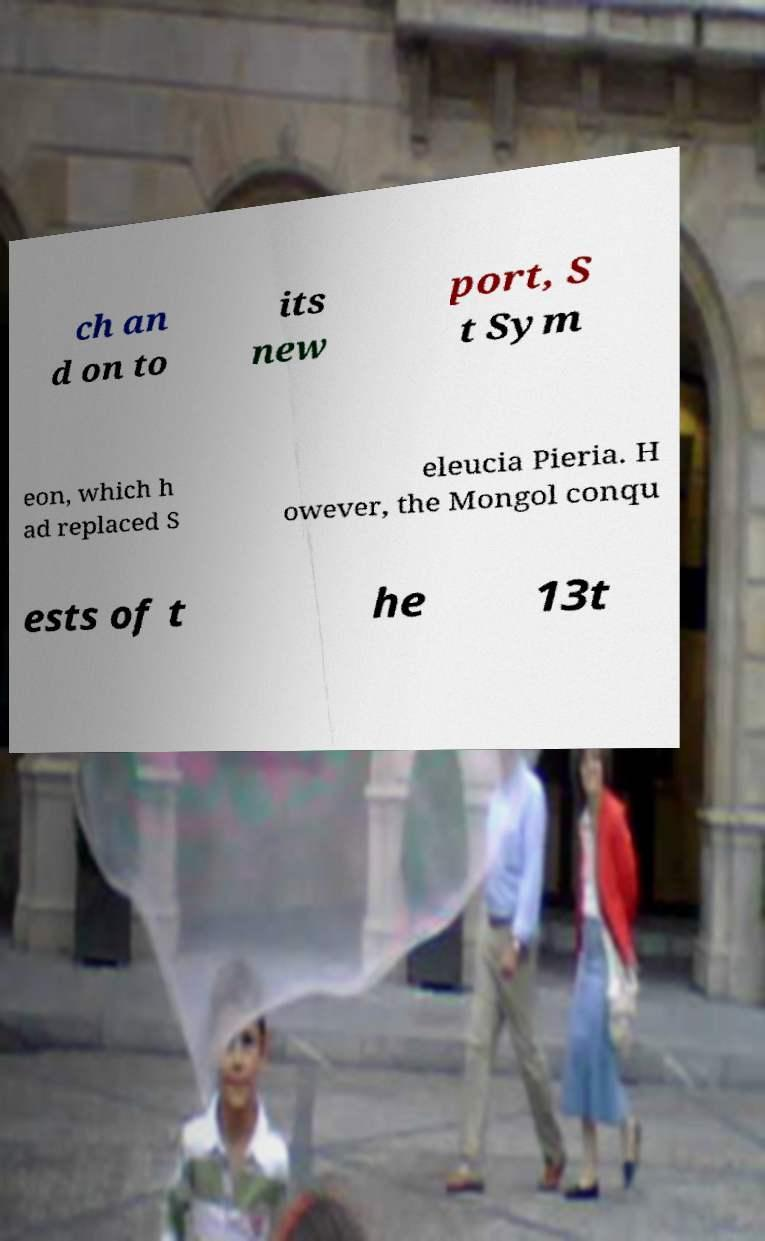Can you read and provide the text displayed in the image?This photo seems to have some interesting text. Can you extract and type it out for me? ch an d on to its new port, S t Sym eon, which h ad replaced S eleucia Pieria. H owever, the Mongol conqu ests of t he 13t 